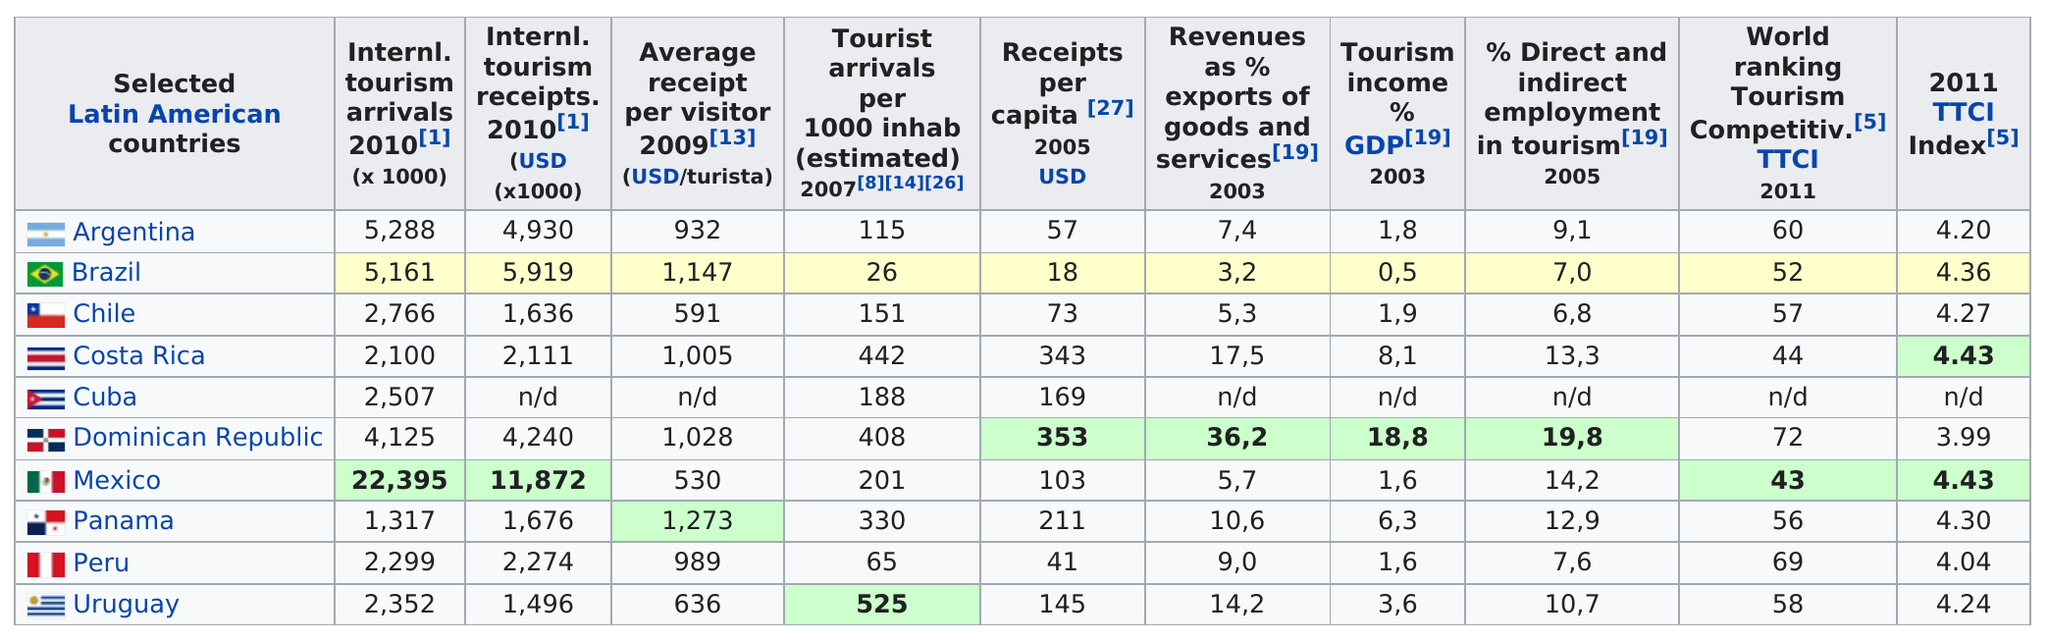Draw attention to some important aspects in this diagram. According to statistics, Mexico is the second country that provides the most employment in the tourism industry. In 2010, Mexico was the country with the most international tourism arrivals. In 2010, Mexico had a total of 22,395 international tourism arrivals, which represented approximately 1.5% of the global total. The Dominican Republic is the country that generates the most tourist income. In 2009, Brazil received an average of 1,147 dollars per tourist. 